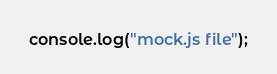<code> <loc_0><loc_0><loc_500><loc_500><_JavaScript_>console.log("mock.js file");</code> 